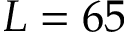<formula> <loc_0><loc_0><loc_500><loc_500>L = 6 5</formula> 